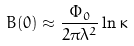<formula> <loc_0><loc_0><loc_500><loc_500>B ( 0 ) \approx \frac { \Phi _ { 0 } } { 2 \pi \lambda ^ { 2 } } \ln \kappa</formula> 